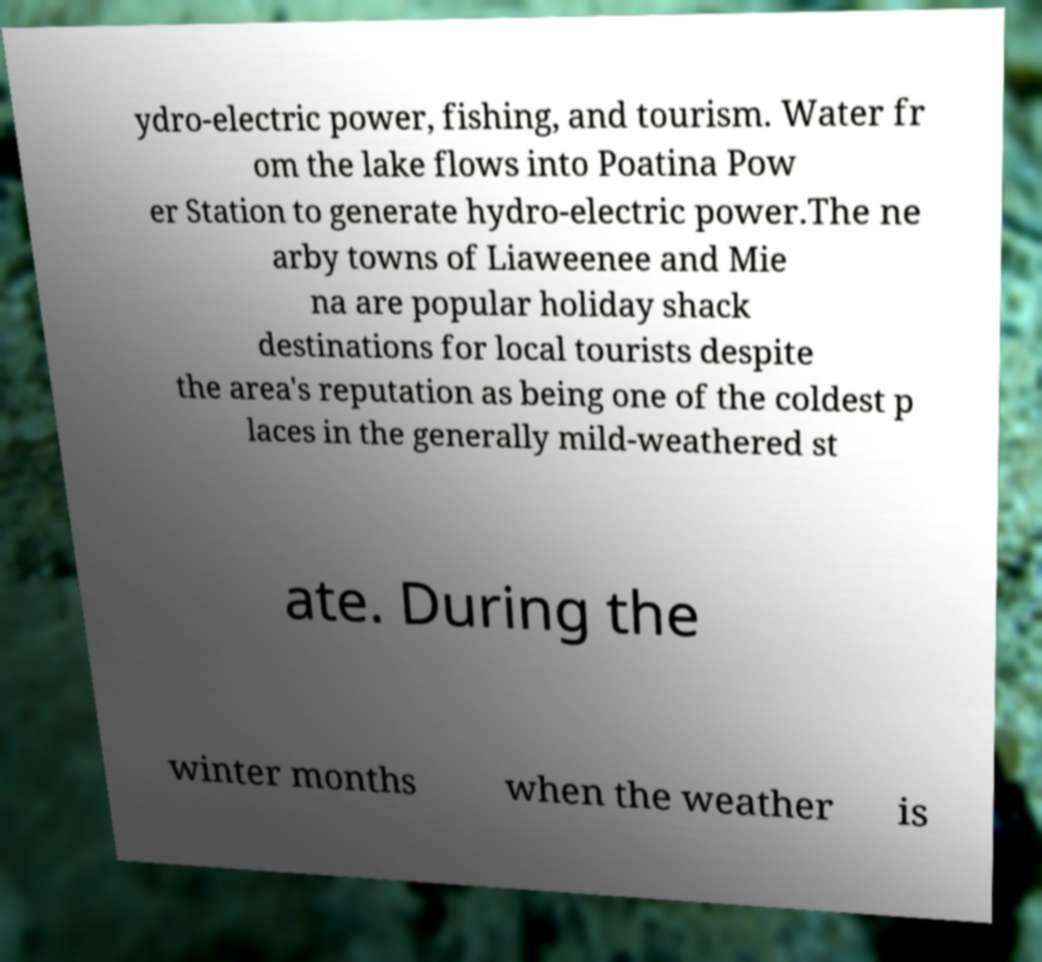What messages or text are displayed in this image? I need them in a readable, typed format. ydro-electric power, fishing, and tourism. Water fr om the lake flows into Poatina Pow er Station to generate hydro-electric power.The ne arby towns of Liaweenee and Mie na are popular holiday shack destinations for local tourists despite the area's reputation as being one of the coldest p laces in the generally mild-weathered st ate. During the winter months when the weather is 